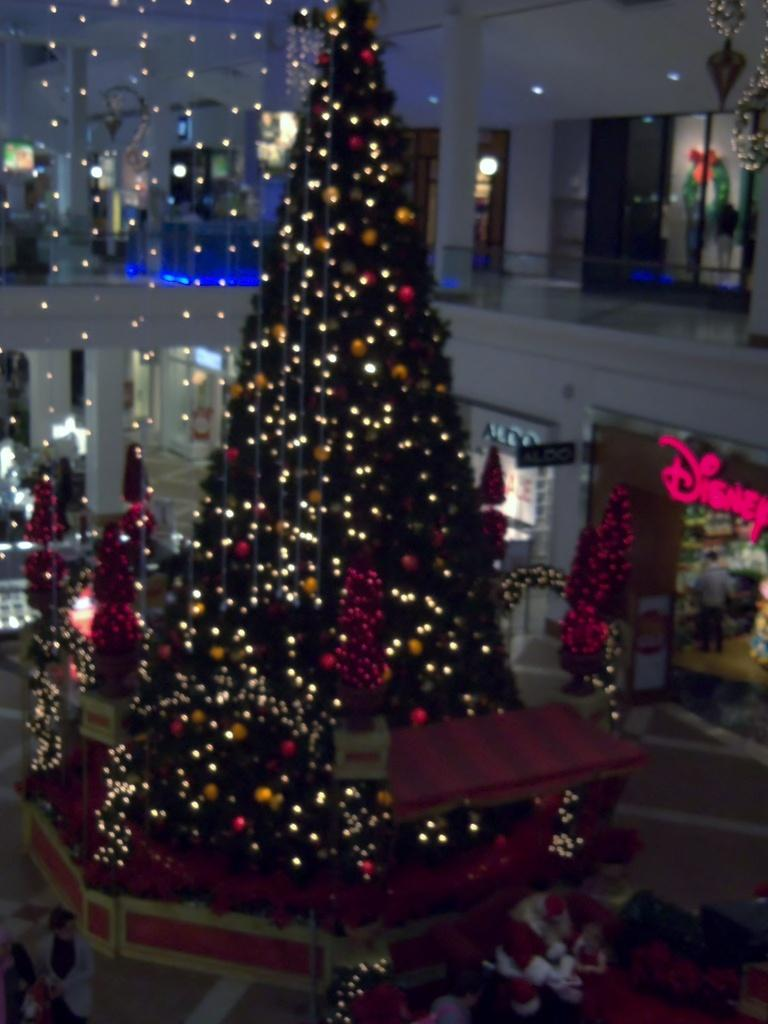What type of location is depicted in the image? The image shows an inner view of a building. What seasonal decoration can be seen in the image? There is a Christmas tree in the image. What type of ornaments are on the Christmas tree? Decorative balls are present on the Christmas tree. How is the Christmas tree illuminated in the image? There is lighting on the Christmas tree. What type of line is used to represent the nation's border on the Christmas tree? There is no representation of a nation's border on the Christmas tree in the image. What type of curve can be seen on the Christmas tree? There are no curves mentioned or visible on the Christmas tree in the image. 